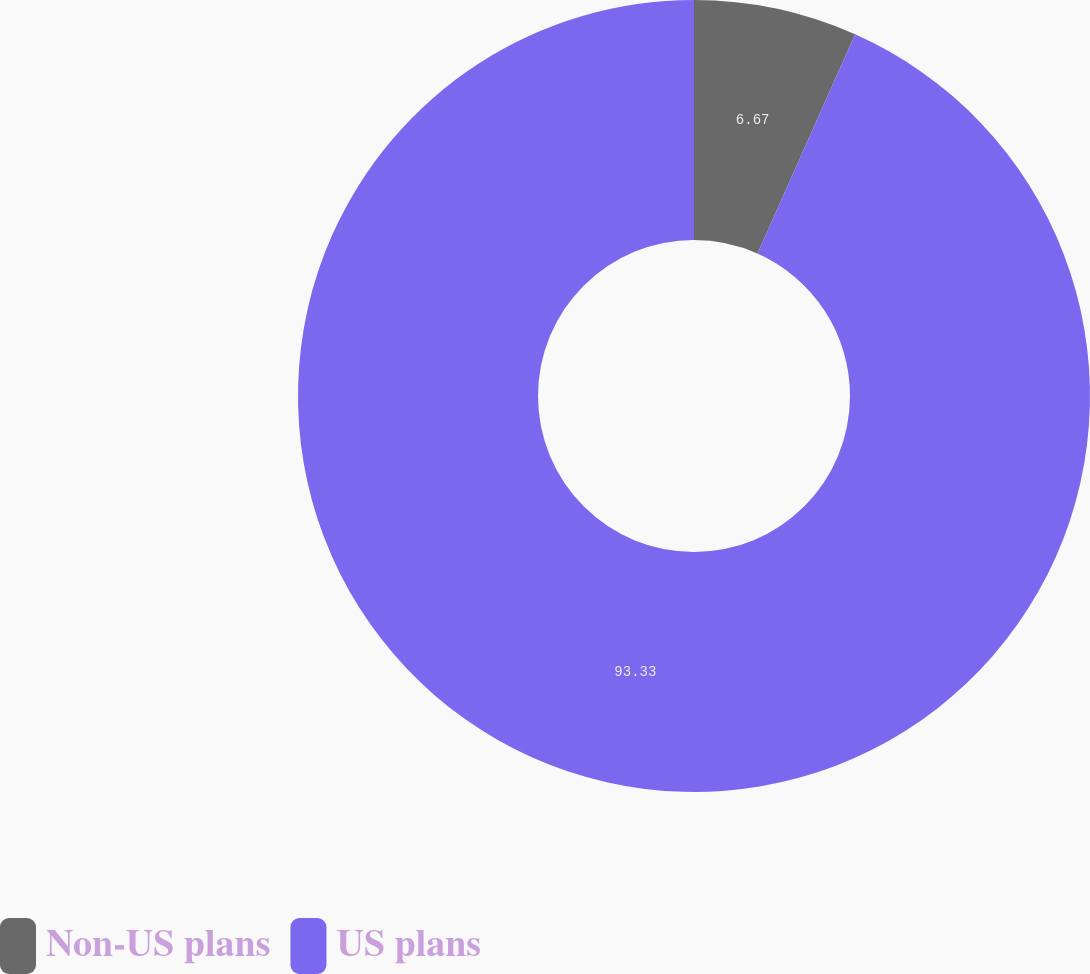Convert chart. <chart><loc_0><loc_0><loc_500><loc_500><pie_chart><fcel>Non-US plans<fcel>US plans<nl><fcel>6.67%<fcel>93.33%<nl></chart> 